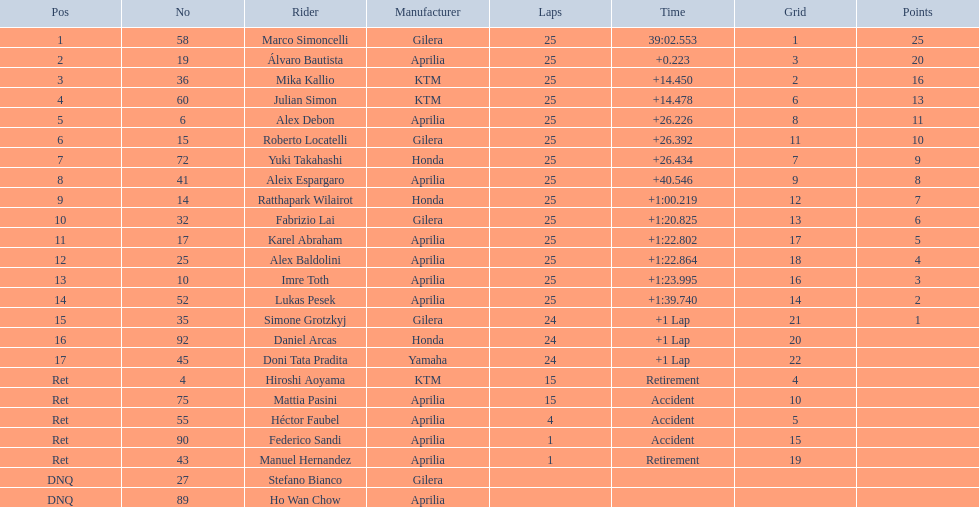How many rounds did hiroshi aoyama make? 15. Could you help me parse every detail presented in this table? {'header': ['Pos', 'No', 'Rider', 'Manufacturer', 'Laps', 'Time', 'Grid', 'Points'], 'rows': [['1', '58', 'Marco Simoncelli', 'Gilera', '25', '39:02.553', '1', '25'], ['2', '19', 'Álvaro Bautista', 'Aprilia', '25', '+0.223', '3', '20'], ['3', '36', 'Mika Kallio', 'KTM', '25', '+14.450', '2', '16'], ['4', '60', 'Julian Simon', 'KTM', '25', '+14.478', '6', '13'], ['5', '6', 'Alex Debon', 'Aprilia', '25', '+26.226', '8', '11'], ['6', '15', 'Roberto Locatelli', 'Gilera', '25', '+26.392', '11', '10'], ['7', '72', 'Yuki Takahashi', 'Honda', '25', '+26.434', '7', '9'], ['8', '41', 'Aleix Espargaro', 'Aprilia', '25', '+40.546', '9', '8'], ['9', '14', 'Ratthapark Wilairot', 'Honda', '25', '+1:00.219', '12', '7'], ['10', '32', 'Fabrizio Lai', 'Gilera', '25', '+1:20.825', '13', '6'], ['11', '17', 'Karel Abraham', 'Aprilia', '25', '+1:22.802', '17', '5'], ['12', '25', 'Alex Baldolini', 'Aprilia', '25', '+1:22.864', '18', '4'], ['13', '10', 'Imre Toth', 'Aprilia', '25', '+1:23.995', '16', '3'], ['14', '52', 'Lukas Pesek', 'Aprilia', '25', '+1:39.740', '14', '2'], ['15', '35', 'Simone Grotzkyj', 'Gilera', '24', '+1 Lap', '21', '1'], ['16', '92', 'Daniel Arcas', 'Honda', '24', '+1 Lap', '20', ''], ['17', '45', 'Doni Tata Pradita', 'Yamaha', '24', '+1 Lap', '22', ''], ['Ret', '4', 'Hiroshi Aoyama', 'KTM', '15', 'Retirement', '4', ''], ['Ret', '75', 'Mattia Pasini', 'Aprilia', '15', 'Accident', '10', ''], ['Ret', '55', 'Héctor Faubel', 'Aprilia', '4', 'Accident', '5', ''], ['Ret', '90', 'Federico Sandi', 'Aprilia', '1', 'Accident', '15', ''], ['Ret', '43', 'Manuel Hernandez', 'Aprilia', '1', 'Retirement', '19', ''], ['DNQ', '27', 'Stefano Bianco', 'Gilera', '', '', '', ''], ['DNQ', '89', 'Ho Wan Chow', 'Aprilia', '', '', '', '']]} How many rounds did marco simoncelli make? 25. Who made more rounds, hiroshi aoyama or marco simoncelli? Marco Simoncelli. 